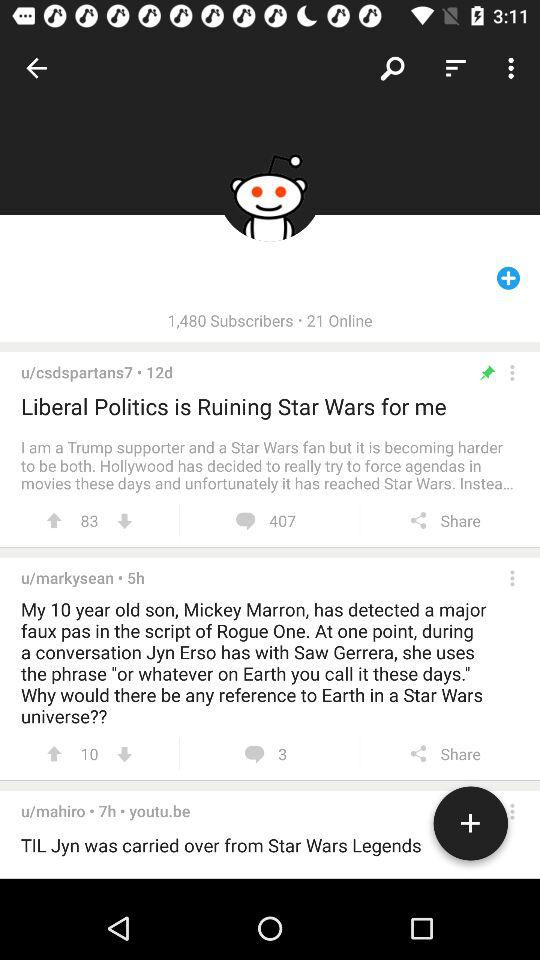What is the number of votes on the "Liberal Politics" topic? There are 83 votes. 